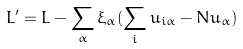<formula> <loc_0><loc_0><loc_500><loc_500>L ^ { \prime } = L - \sum _ { \alpha } \xi _ { \alpha } ( \sum _ { i } u _ { i \alpha } - N u _ { \alpha } )</formula> 